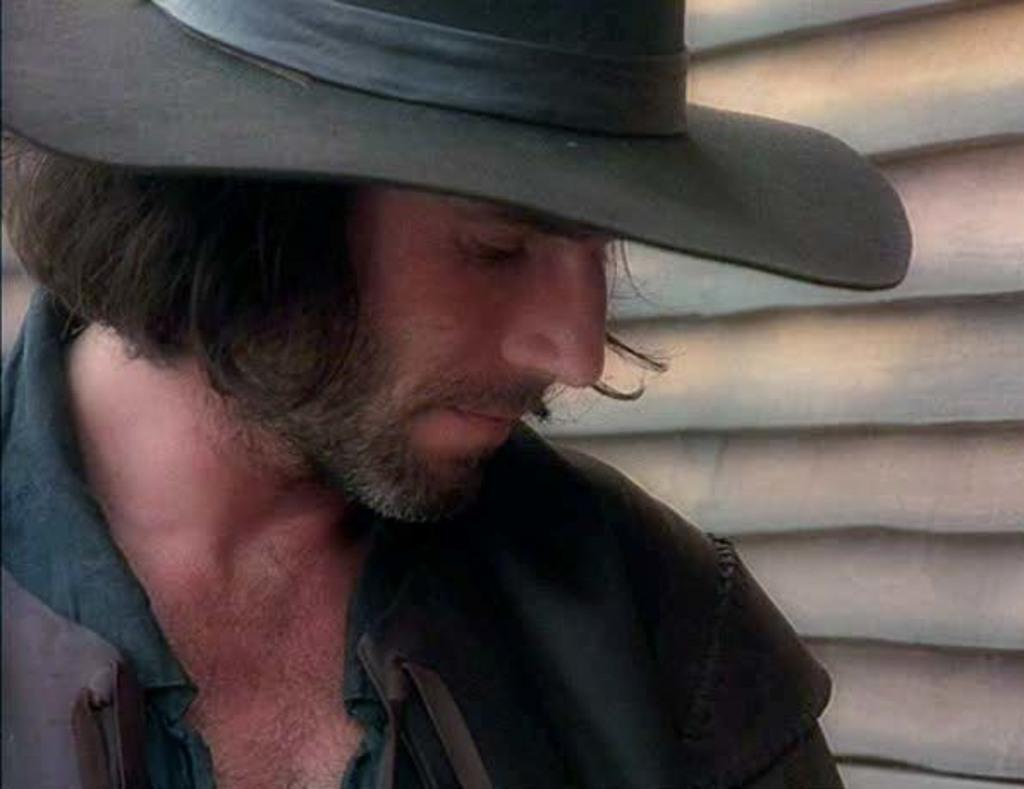Who is present in the image? There is a man in the image. What is the man wearing? The man is wearing clothes and a hat. What can be seen in the background of the image? There is a wall in the background of the image. What type of juice is the man drinking in the image? There is no juice present in the image; the man is not shown drinking anything. 